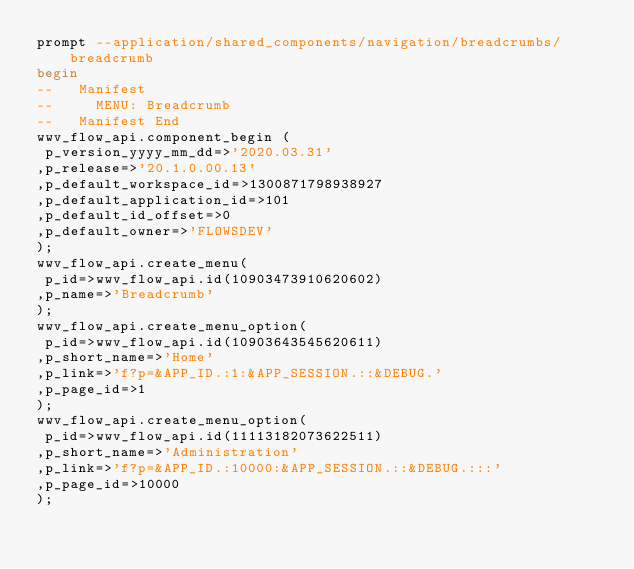Convert code to text. <code><loc_0><loc_0><loc_500><loc_500><_SQL_>prompt --application/shared_components/navigation/breadcrumbs/breadcrumb
begin
--   Manifest
--     MENU: Breadcrumb
--   Manifest End
wwv_flow_api.component_begin (
 p_version_yyyy_mm_dd=>'2020.03.31'
,p_release=>'20.1.0.00.13'
,p_default_workspace_id=>1300871798938927
,p_default_application_id=>101
,p_default_id_offset=>0
,p_default_owner=>'FLOWSDEV'
);
wwv_flow_api.create_menu(
 p_id=>wwv_flow_api.id(10903473910620602)
,p_name=>'Breadcrumb'
);
wwv_flow_api.create_menu_option(
 p_id=>wwv_flow_api.id(10903643545620611)
,p_short_name=>'Home'
,p_link=>'f?p=&APP_ID.:1:&APP_SESSION.::&DEBUG.'
,p_page_id=>1
);
wwv_flow_api.create_menu_option(
 p_id=>wwv_flow_api.id(11113182073622511)
,p_short_name=>'Administration'
,p_link=>'f?p=&APP_ID.:10000:&APP_SESSION.::&DEBUG.:::'
,p_page_id=>10000
);</code> 